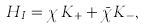<formula> <loc_0><loc_0><loc_500><loc_500>H _ { I } = \chi \, K _ { + } + \bar { \chi } K _ { - } ,</formula> 